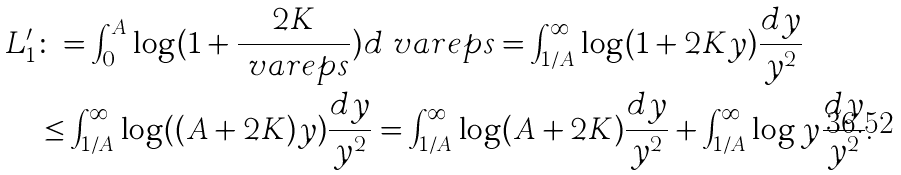<formula> <loc_0><loc_0><loc_500><loc_500>L ^ { \prime } _ { 1 } & \colon = \int _ { 0 } ^ { A } \log ( 1 + \frac { 2 K } { \ v a r e p s } ) d \ v a r e p s = \int _ { 1 / A } ^ { \infty } \log ( 1 + 2 K y ) \frac { d y } { y ^ { 2 } } \\ & \leq \int _ { 1 / A } ^ { \infty } \log ( ( A + 2 K ) y ) \frac { d y } { y ^ { 2 } } = \int _ { 1 / A } ^ { \infty } \log ( A + 2 K ) \frac { d y } { y ^ { 2 } } + \int _ { 1 / A } ^ { \infty } \log y \frac { d y } { y ^ { 2 } } .</formula> 